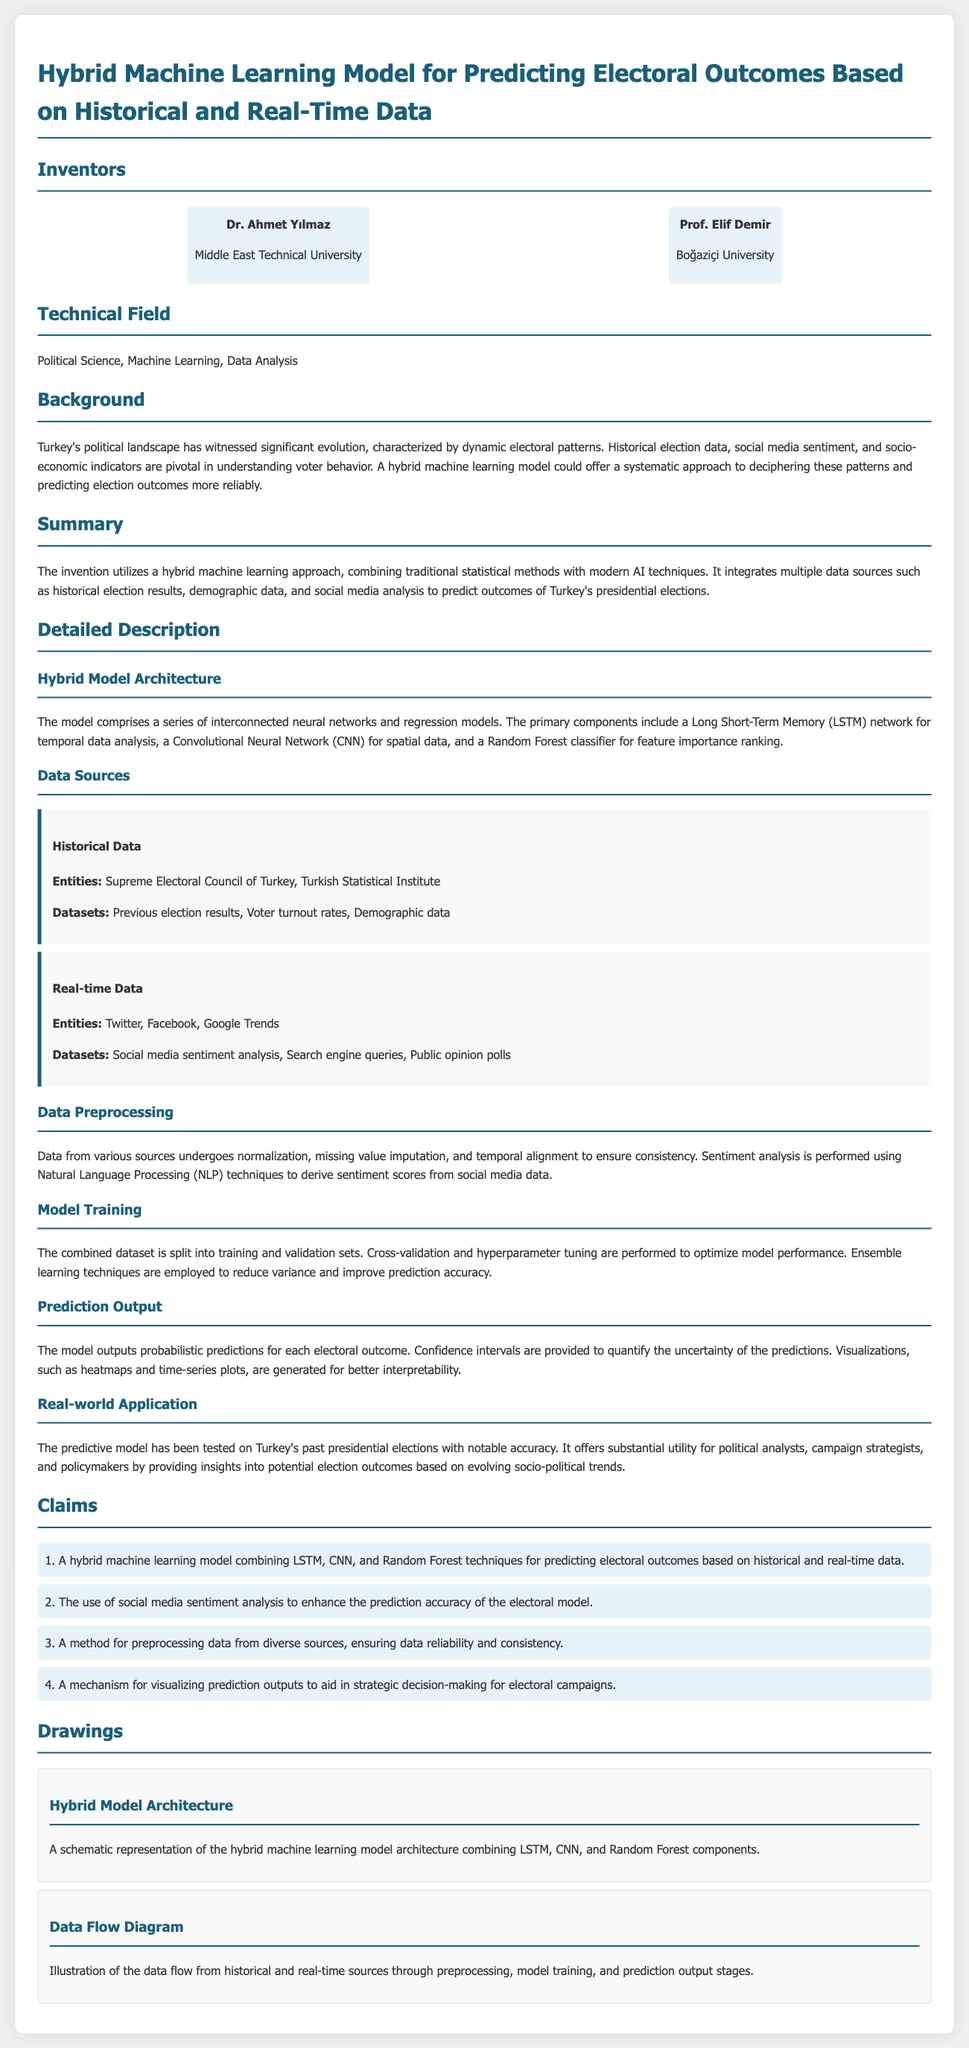What are the names of the inventors? The document lists the inventors as Dr. Ahmet Yılmaz and Prof. Elif Demir.
Answer: Dr. Ahmet Yılmaz, Prof. Elif Demir What is the primary technical field of the patent? The patent application relates to multiple fields, specifically mentioned as Political Science, Machine Learning, and Data Analysis.
Answer: Political Science, Machine Learning, Data Analysis Which machine learning techniques are combined in the model? The model combines LSTM, CNN, and Random Forest techniques according to the claims section of the document.
Answer: LSTM, CNN, Random Forest What entities provide historical data for the model? Historical data is sourced from the Supreme Electoral Council of Turkey and the Turkish Statistical Institute as outlined in the data source section.
Answer: Supreme Electoral Council of Turkey, Turkish Statistical Institute What is the purpose of the hybrid machine learning model? The purpose is to predict electoral outcomes based on historical and real-time data according to the summary of the document.
Answer: Predicting electoral outcomes How does the model enhance prediction accuracy? The model enhances prediction accuracy by using social media sentiment analysis as mentioned in the claims.
Answer: Social media sentiment analysis What is the significance of the predictions provided by the model? The predictions are significant for political analysts, campaign strategists, and policymakers, allowing them to gain insights into potential election outcomes.
Answer: Insights into potential election outcomes What type of data preprocessing techniques are mentioned? The document mentions normalization, missing value imputation, and temporal alignment as preprocessing techniques used for data consistency.
Answer: Normalization, missing value imputation, temporal alignment How is the prediction output presented? The model outputs are presented with probabilistic predictions and confidence intervals for understanding uncertainty as stated in the prediction output section.
Answer: Probabilistic predictions and confidence intervals 